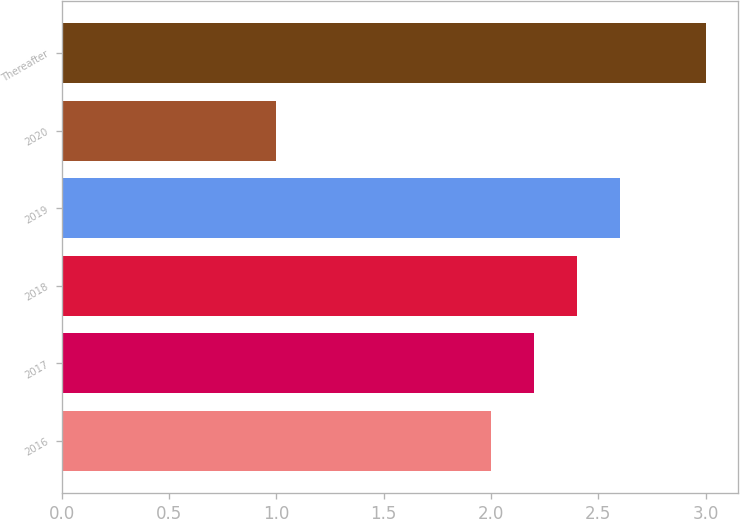<chart> <loc_0><loc_0><loc_500><loc_500><bar_chart><fcel>2016<fcel>2017<fcel>2018<fcel>2019<fcel>2020<fcel>Thereafter<nl><fcel>2<fcel>2.2<fcel>2.4<fcel>2.6<fcel>1<fcel>3<nl></chart> 